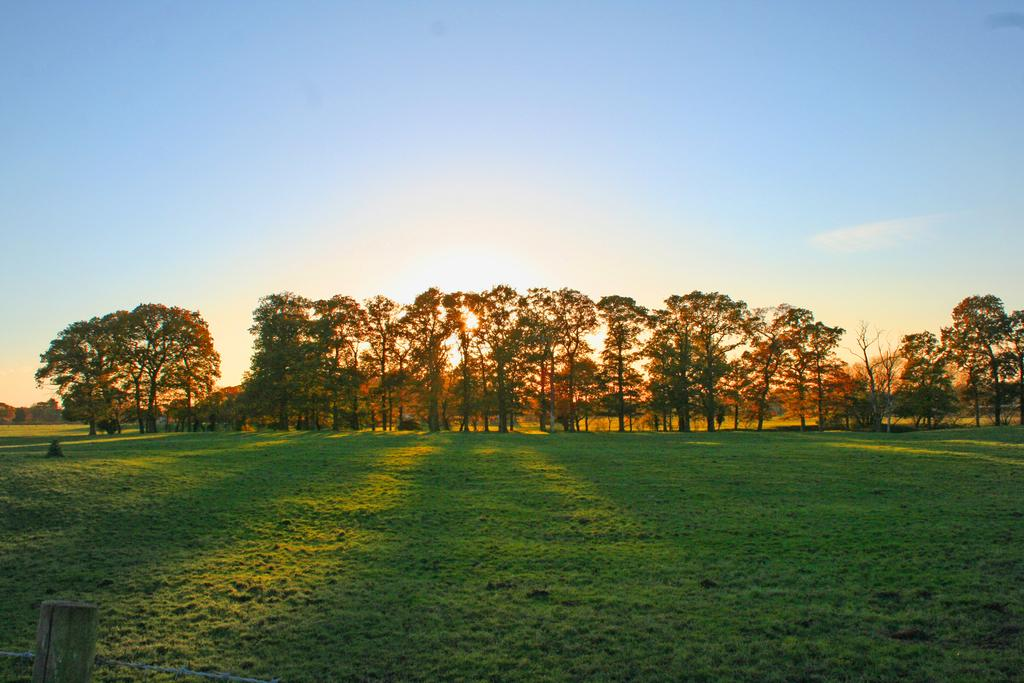What type of vegetation can be seen in the foreground of the picture? There is grass in the foreground of the picture. What other natural elements are present in the picture? There are trees in the center of the picture. What is the weather like in the image? The sun is shining in the sky in the background of the image, indicating a sunny day. What type of teeth can be seen in the picture? There are no teeth visible in the picture; it features grass, trees, and the sun. What financial interest is represented in the picture? There is no financial interest represented in the picture; it is a natural scene with grass, trees, and the sun. 